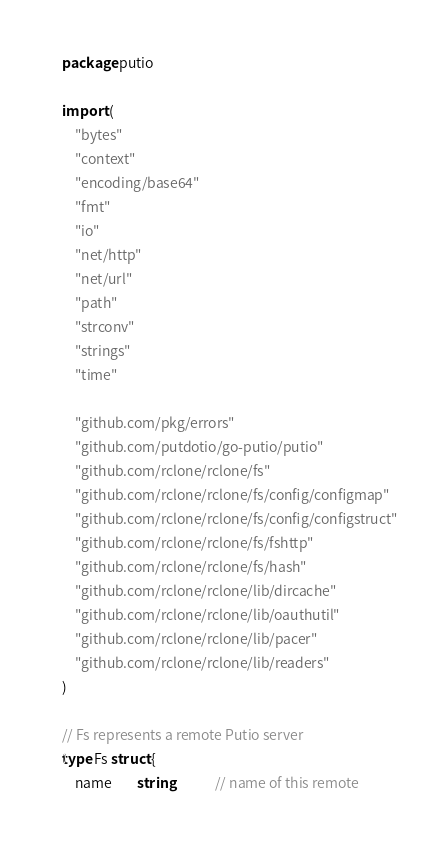<code> <loc_0><loc_0><loc_500><loc_500><_Go_>package putio

import (
	"bytes"
	"context"
	"encoding/base64"
	"fmt"
	"io"
	"net/http"
	"net/url"
	"path"
	"strconv"
	"strings"
	"time"

	"github.com/pkg/errors"
	"github.com/putdotio/go-putio/putio"
	"github.com/rclone/rclone/fs"
	"github.com/rclone/rclone/fs/config/configmap"
	"github.com/rclone/rclone/fs/config/configstruct"
	"github.com/rclone/rclone/fs/fshttp"
	"github.com/rclone/rclone/fs/hash"
	"github.com/rclone/rclone/lib/dircache"
	"github.com/rclone/rclone/lib/oauthutil"
	"github.com/rclone/rclone/lib/pacer"
	"github.com/rclone/rclone/lib/readers"
)

// Fs represents a remote Putio server
type Fs struct {
	name        string             // name of this remote</code> 